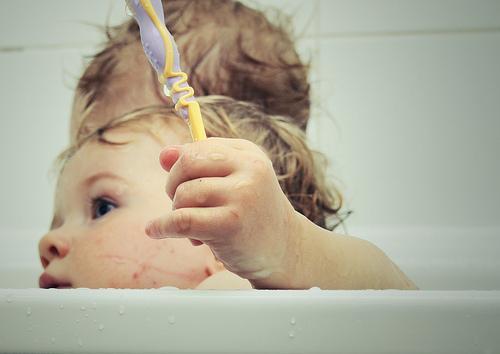How many children are in the picture?
Give a very brief answer. 2. How many people are there?
Give a very brief answer. 2. 